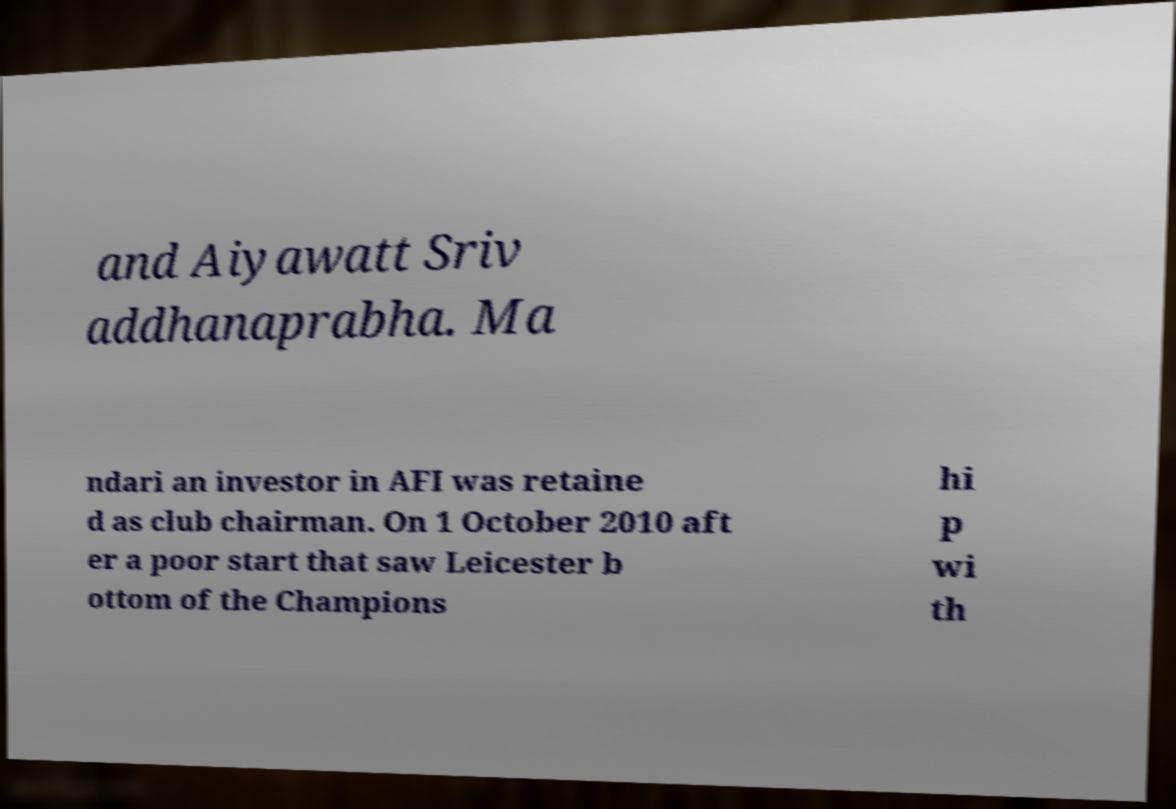There's text embedded in this image that I need extracted. Can you transcribe it verbatim? and Aiyawatt Sriv addhanaprabha. Ma ndari an investor in AFI was retaine d as club chairman. On 1 October 2010 aft er a poor start that saw Leicester b ottom of the Champions hi p wi th 